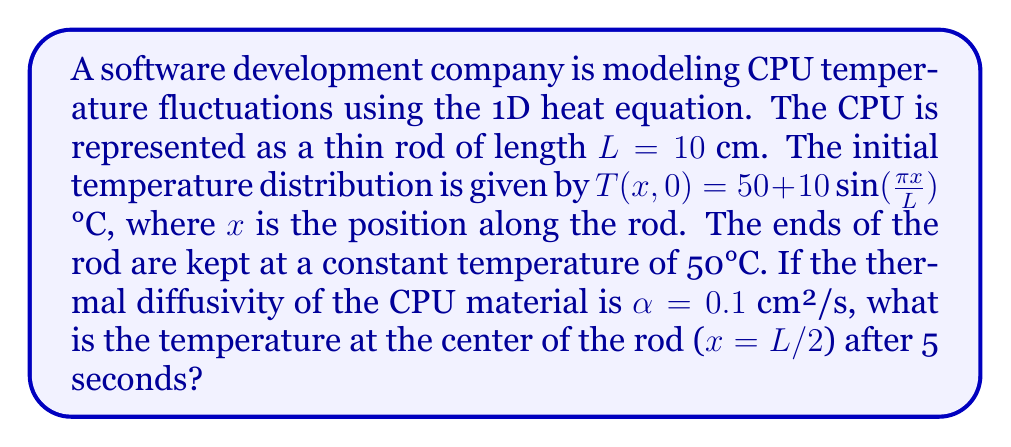Provide a solution to this math problem. To solve this problem, we'll use the separation of variables method for the 1D heat equation:

1) The heat equation is given by:
   $$\frac{\partial T}{\partial t} = \alpha \frac{\partial^2 T}{\partial x^2}$$

2) With boundary conditions: $T(0,t) = T(L,t) = 50$°C
   And initial condition: $T(x,0) = 50 + 10\sin(\frac{\pi x}{L})$°C

3) The general solution for this problem is:
   $$T(x,t) = 50 + \sum_{n=1}^{\infty} B_n \sin(\frac{n\pi x}{L}) e^{-\alpha(\frac{n\pi}{L})^2 t}$$

4) From the initial condition, we can see that only the first term (n=1) is non-zero:
   $$B_1 = 10, B_n = 0 \text{ for } n > 1$$

5) Therefore, our solution simplifies to:
   $$T(x,t) = 50 + 10 \sin(\frac{\pi x}{L}) e^{-\alpha(\frac{\pi}{L})^2 t}$$

6) Now, let's plug in our values:
   - x = L/2 = 5 cm (center of the rod)
   - t = 5 s
   - L = 10 cm
   - α = 0.1 cm²/s

7) Calculating:
   $$T(5,5) = 50 + 10 \sin(\frac{\pi 5}{10}) e^{-0.1(\frac{\pi}{10})^2 5}$$
   $$= 50 + 10 \sin(\frac{\pi}{2}) e^{-0.1(\frac{\pi^2}{100}) 5}$$
   $$= 50 + 10 \cdot 1 \cdot e^{-0.0493}$$
   $$= 50 + 10 \cdot 0.9519$$
   $$= 59.519$$°C

Therefore, the temperature at the center of the rod after 5 seconds is approximately 59.519°C.
Answer: 59.519°C 